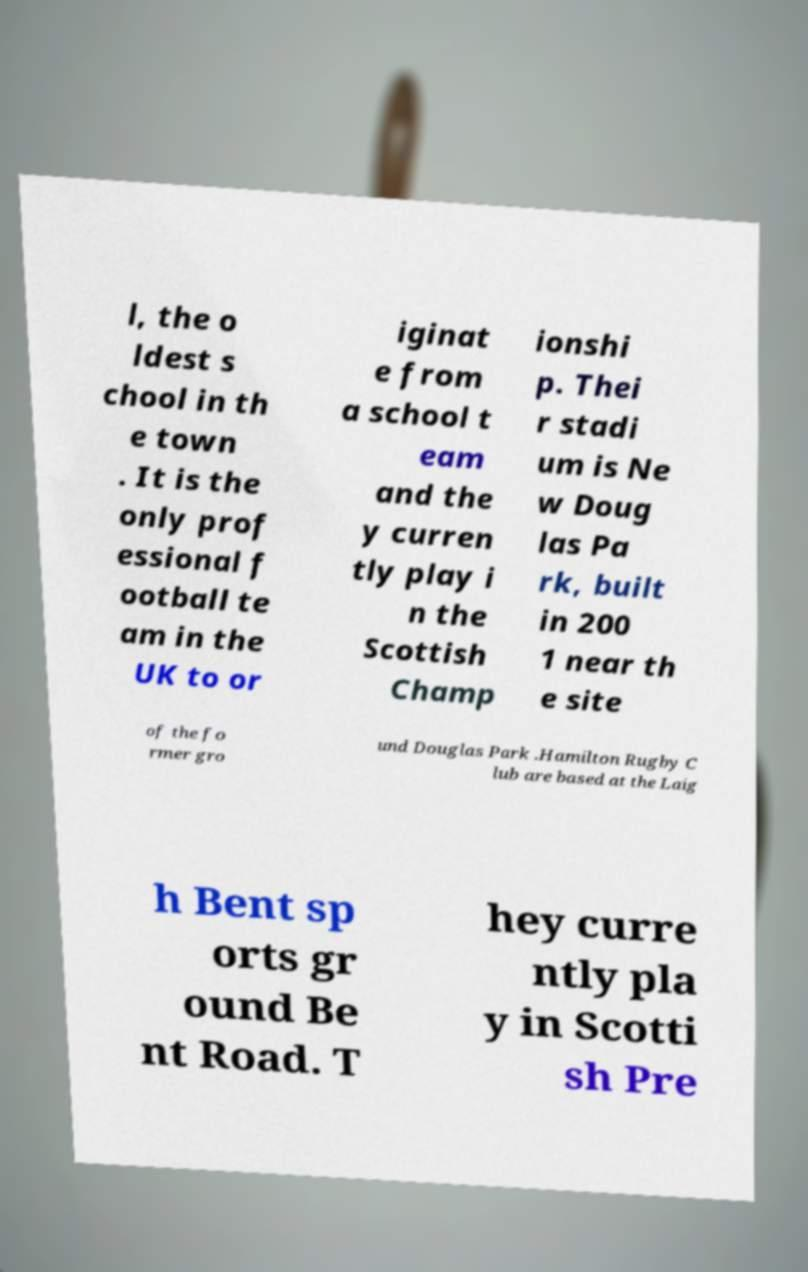Can you accurately transcribe the text from the provided image for me? l, the o ldest s chool in th e town . It is the only prof essional f ootball te am in the UK to or iginat e from a school t eam and the y curren tly play i n the Scottish Champ ionshi p. Thei r stadi um is Ne w Doug las Pa rk, built in 200 1 near th e site of the fo rmer gro und Douglas Park .Hamilton Rugby C lub are based at the Laig h Bent sp orts gr ound Be nt Road. T hey curre ntly pla y in Scotti sh Pre 